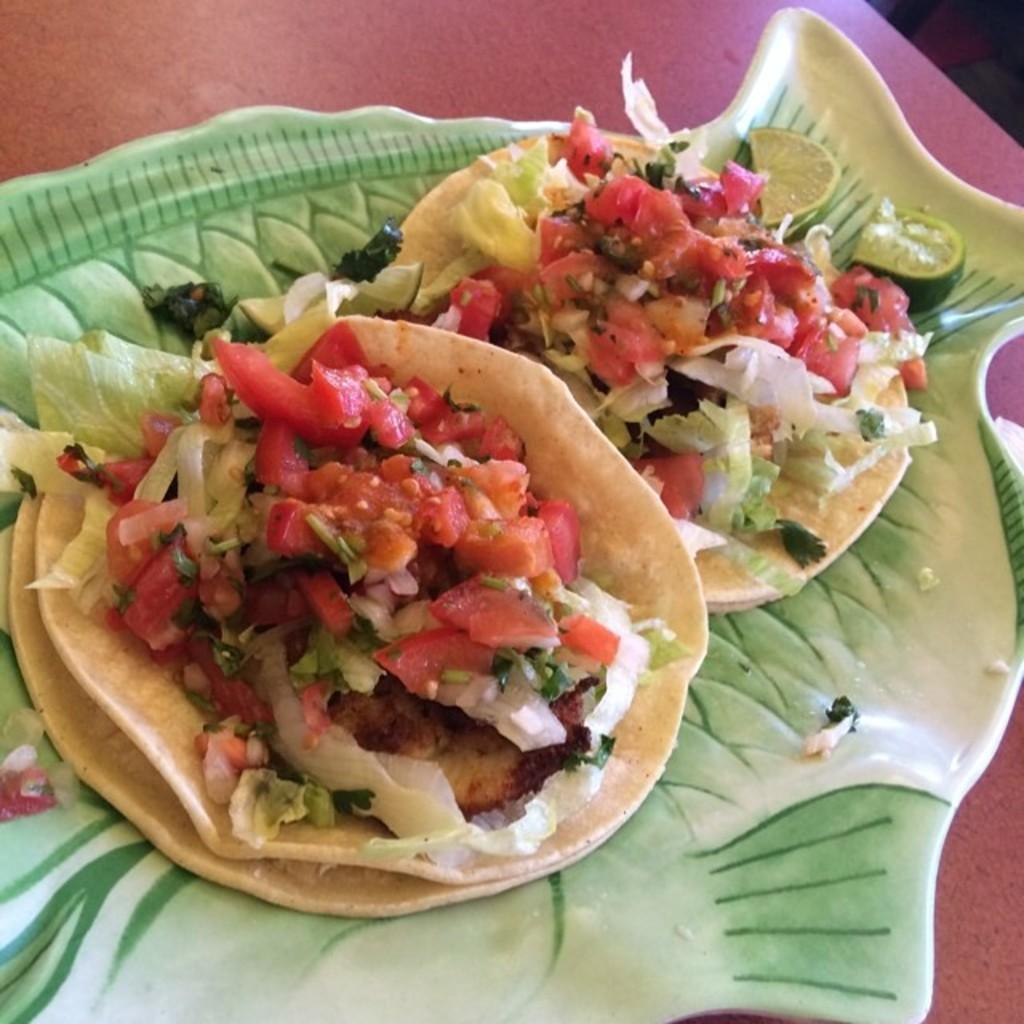Describe this image in one or two sentences. In this image I can see a food items on the green and white color plate. Food is in red,orange,white and cream color. Plate is on the red table. 